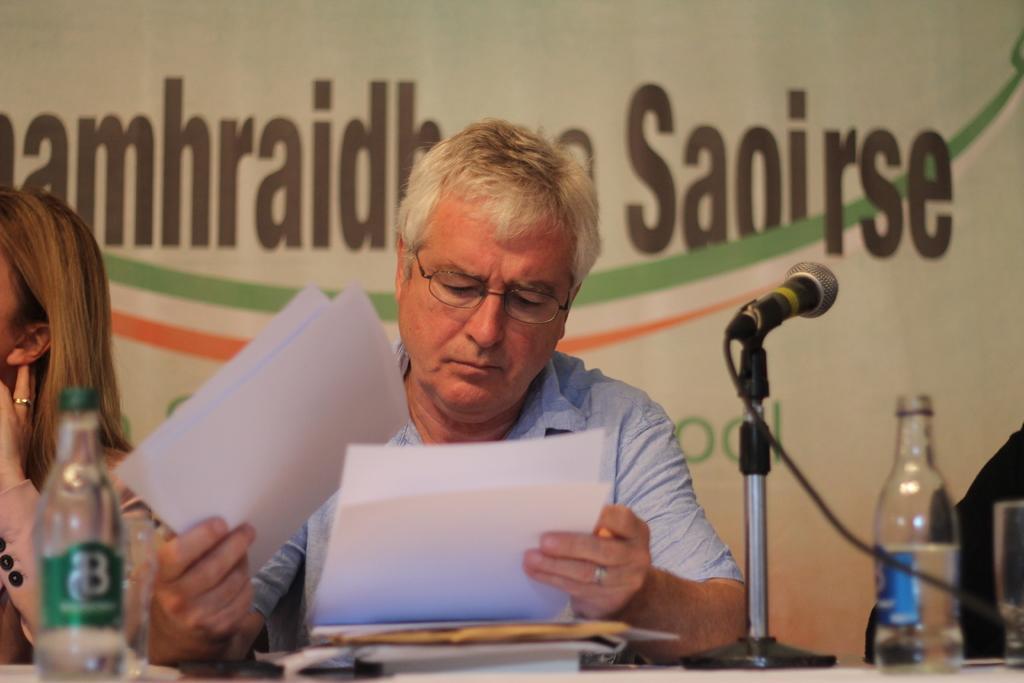Describe this image in one or two sentences. In this picture a person is sitting on the chair and holding some papers and watching to the papers. In front of him there is a mic and a cable attached to the mic there are some bottles placed in front of him on the table beside him a lady with the pink colored shirt having a ring to her finger. In the background i could see some text written on the banner and the person sitting in front in the picture is having a glasses. 